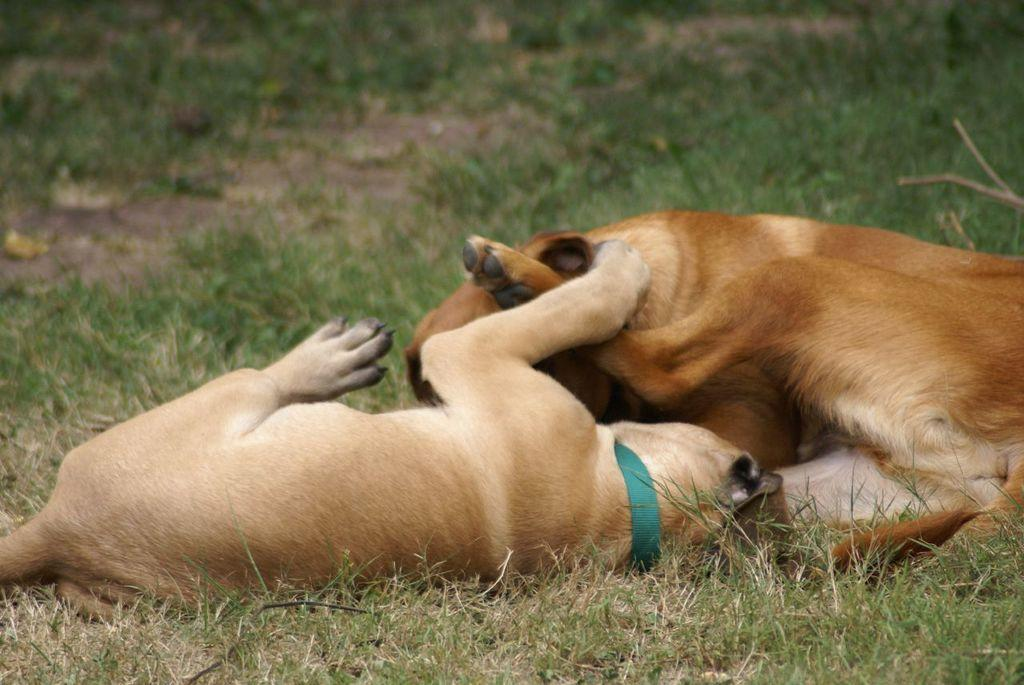How many dogs are present in the image? There are two dogs in the image. What are the dogs doing in the image? The dogs are lying on the ground. What type of surface are the dogs lying on? There is grass on the ground where the dogs are lying. What type of whip can be seen in the image? There is no whip present in the image. How many men are visible in the image? There are no men present in the image; it only features two dogs lying on the grass. 